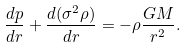<formula> <loc_0><loc_0><loc_500><loc_500>\frac { d p } { d r } + \frac { d ( \sigma ^ { 2 } \rho ) } { d r } = - \rho \frac { G M } { r ^ { 2 } } .</formula> 